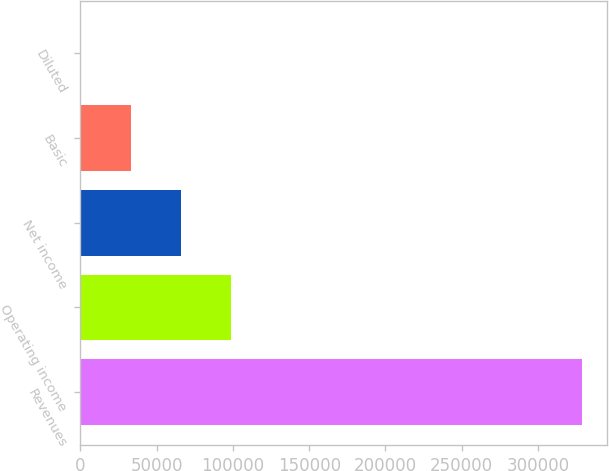<chart> <loc_0><loc_0><loc_500><loc_500><bar_chart><fcel>Revenues<fcel>Operating income<fcel>Net income<fcel>Basic<fcel>Diluted<nl><fcel>328827<fcel>98648.3<fcel>65765.6<fcel>32882.9<fcel>0.26<nl></chart> 